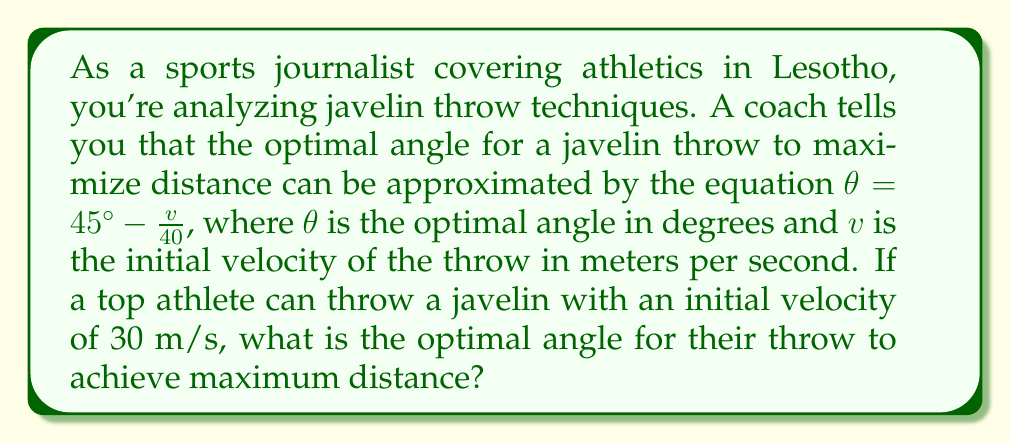Teach me how to tackle this problem. To solve this problem, we'll follow these steps:

1) We're given the equation: $\theta = 45^\circ - \frac{v}{40}$

2) We're also given that $v = 30$ m/s for this athlete.

3) Let's substitute $v = 30$ into the equation:

   $\theta = 45^\circ - \frac{30}{40}$

4) Simplify the fraction:
   
   $\theta = 45^\circ - 0.75$

5) Subtract:

   $\theta = 44.25^\circ$

Therefore, the optimal angle for this athlete's javelin throw to maximize distance is 44.25°.

This result aligns with physics principles. The 45° angle would be optimal in a vacuum, but air resistance slightly reduces the optimal angle. The faster the throw, the more the optimal angle decreases from 45°.
Answer: $44.25^\circ$ 